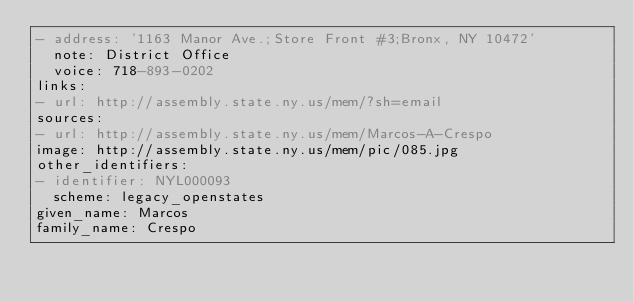<code> <loc_0><loc_0><loc_500><loc_500><_YAML_>- address: '1163 Manor Ave.;Store Front #3;Bronx, NY 10472'
  note: District Office
  voice: 718-893-0202
links:
- url: http://assembly.state.ny.us/mem/?sh=email
sources:
- url: http://assembly.state.ny.us/mem/Marcos-A-Crespo
image: http://assembly.state.ny.us/mem/pic/085.jpg
other_identifiers:
- identifier: NYL000093
  scheme: legacy_openstates
given_name: Marcos
family_name: Crespo
</code> 